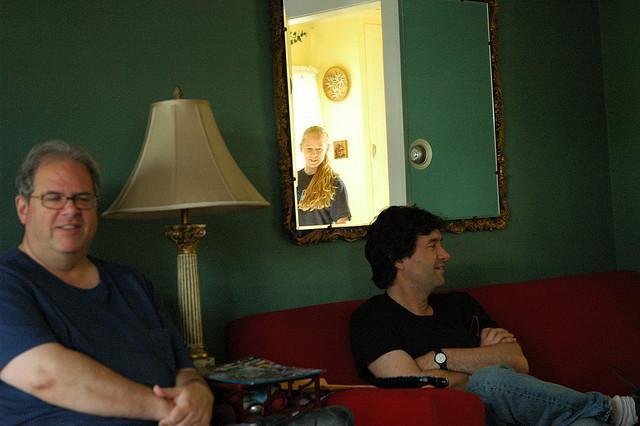How many people are there?
Give a very brief answer. 3. How many couches are there?
Give a very brief answer. 1. How many pizza slices are missing from the tray?
Give a very brief answer. 0. 